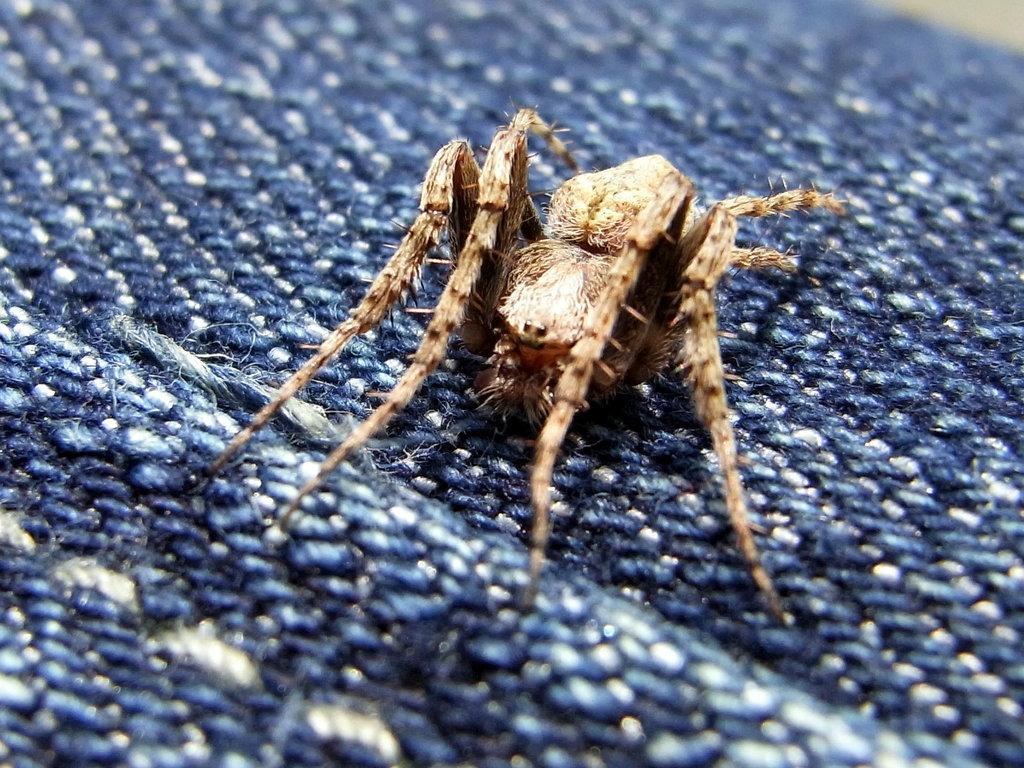How would you summarize this image in a sentence or two? Here we can see an insect on the surface. 